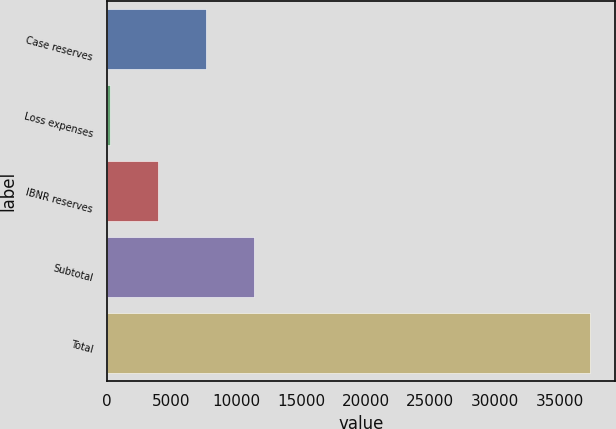<chart> <loc_0><loc_0><loc_500><loc_500><bar_chart><fcel>Case reserves<fcel>Loss expenses<fcel>IBNR reserves<fcel>Subtotal<fcel>Total<nl><fcel>7665.4<fcel>234<fcel>3949.7<fcel>11381.1<fcel>37391<nl></chart> 